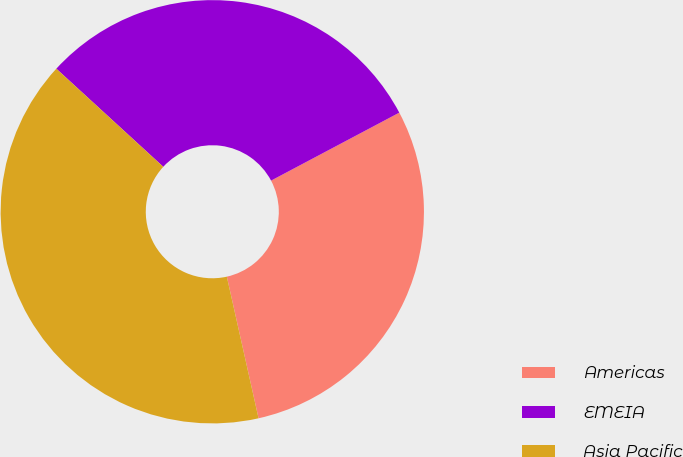<chart> <loc_0><loc_0><loc_500><loc_500><pie_chart><fcel>Americas<fcel>EMEIA<fcel>Asia Pacific<nl><fcel>29.25%<fcel>30.43%<fcel>40.32%<nl></chart> 